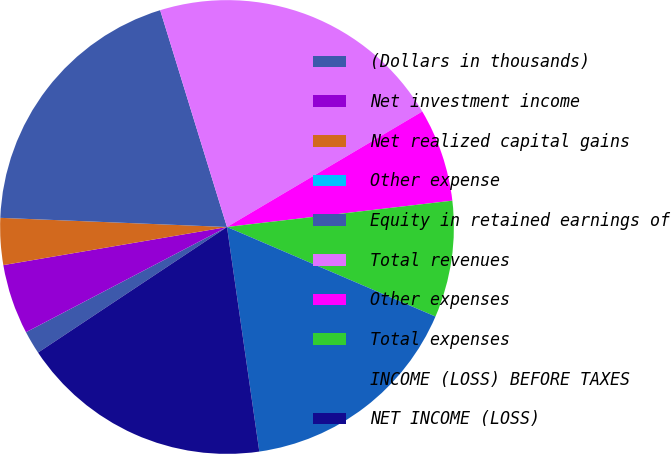<chart> <loc_0><loc_0><loc_500><loc_500><pie_chart><fcel>(Dollars in thousands)<fcel>Net investment income<fcel>Net realized capital gains<fcel>Other expense<fcel>Equity in retained earnings of<fcel>Total revenues<fcel>Other expenses<fcel>Total expenses<fcel>INCOME (LOSS) BEFORE TAXES<fcel>NET INCOME (LOSS)<nl><fcel>1.66%<fcel>4.99%<fcel>3.33%<fcel>0.0%<fcel>19.6%<fcel>21.26%<fcel>6.65%<fcel>8.31%<fcel>16.27%<fcel>17.94%<nl></chart> 